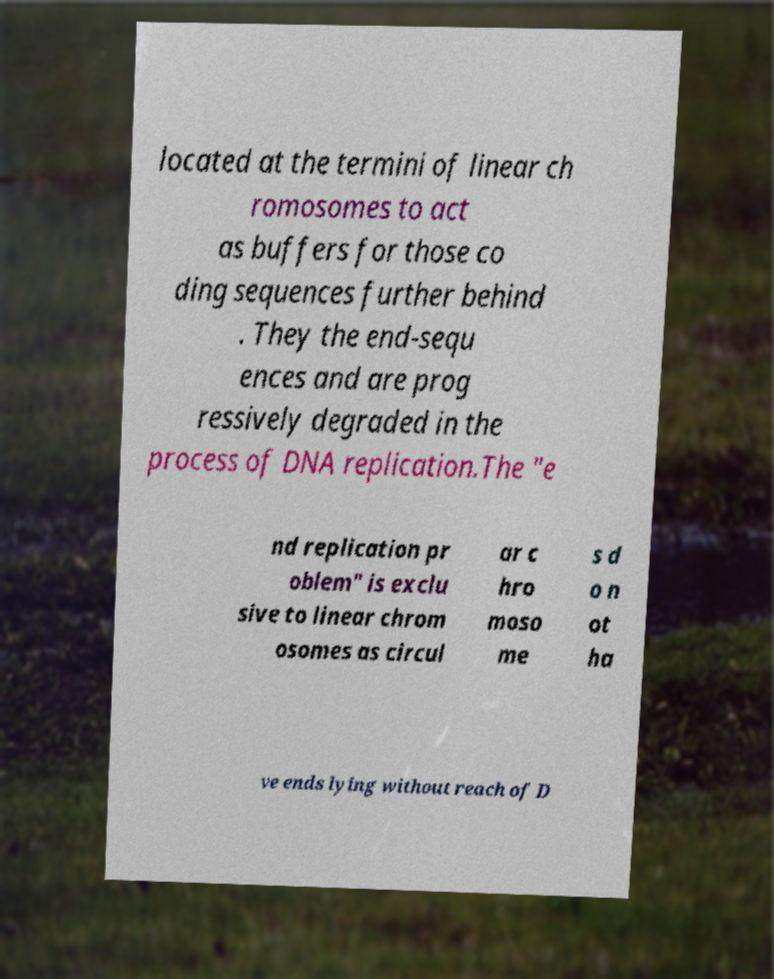What messages or text are displayed in this image? I need them in a readable, typed format. located at the termini of linear ch romosomes to act as buffers for those co ding sequences further behind . They the end-sequ ences and are prog ressively degraded in the process of DNA replication.The "e nd replication pr oblem" is exclu sive to linear chrom osomes as circul ar c hro moso me s d o n ot ha ve ends lying without reach of D 